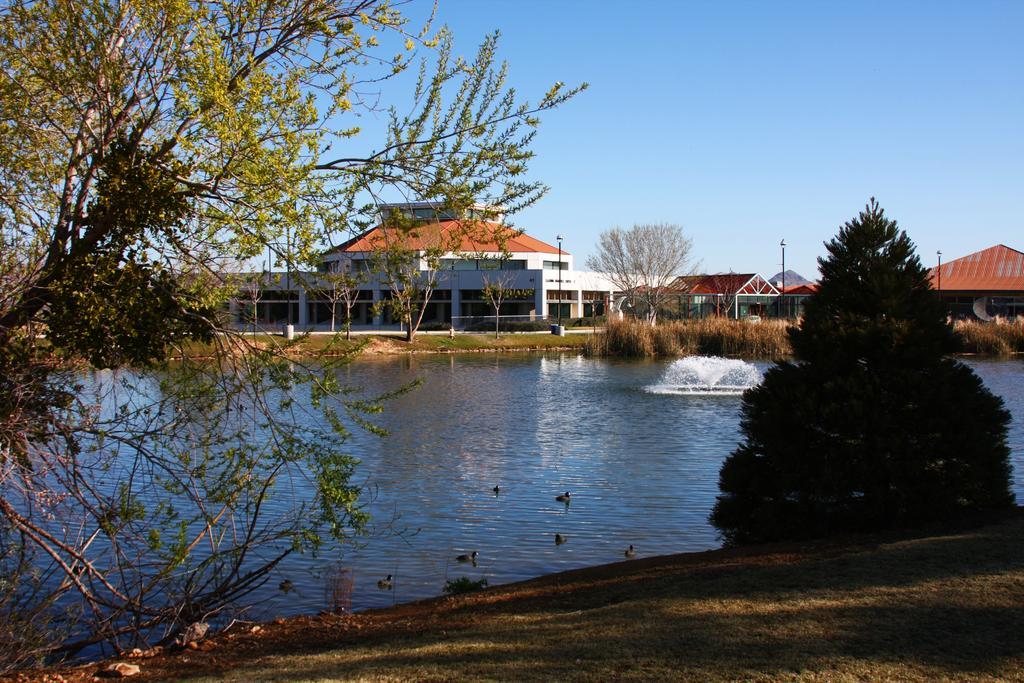Could you give a brief overview of what you see in this image? In this image I can see trees in green color, a fountain, buildings in white and brown color, few light poles and the sky is in blue color. 